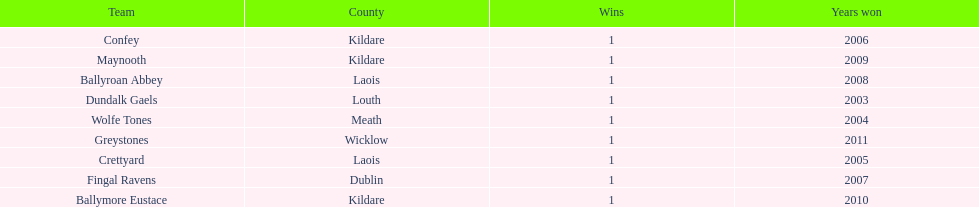What is the difference years won for crettyard and greystones 6. 